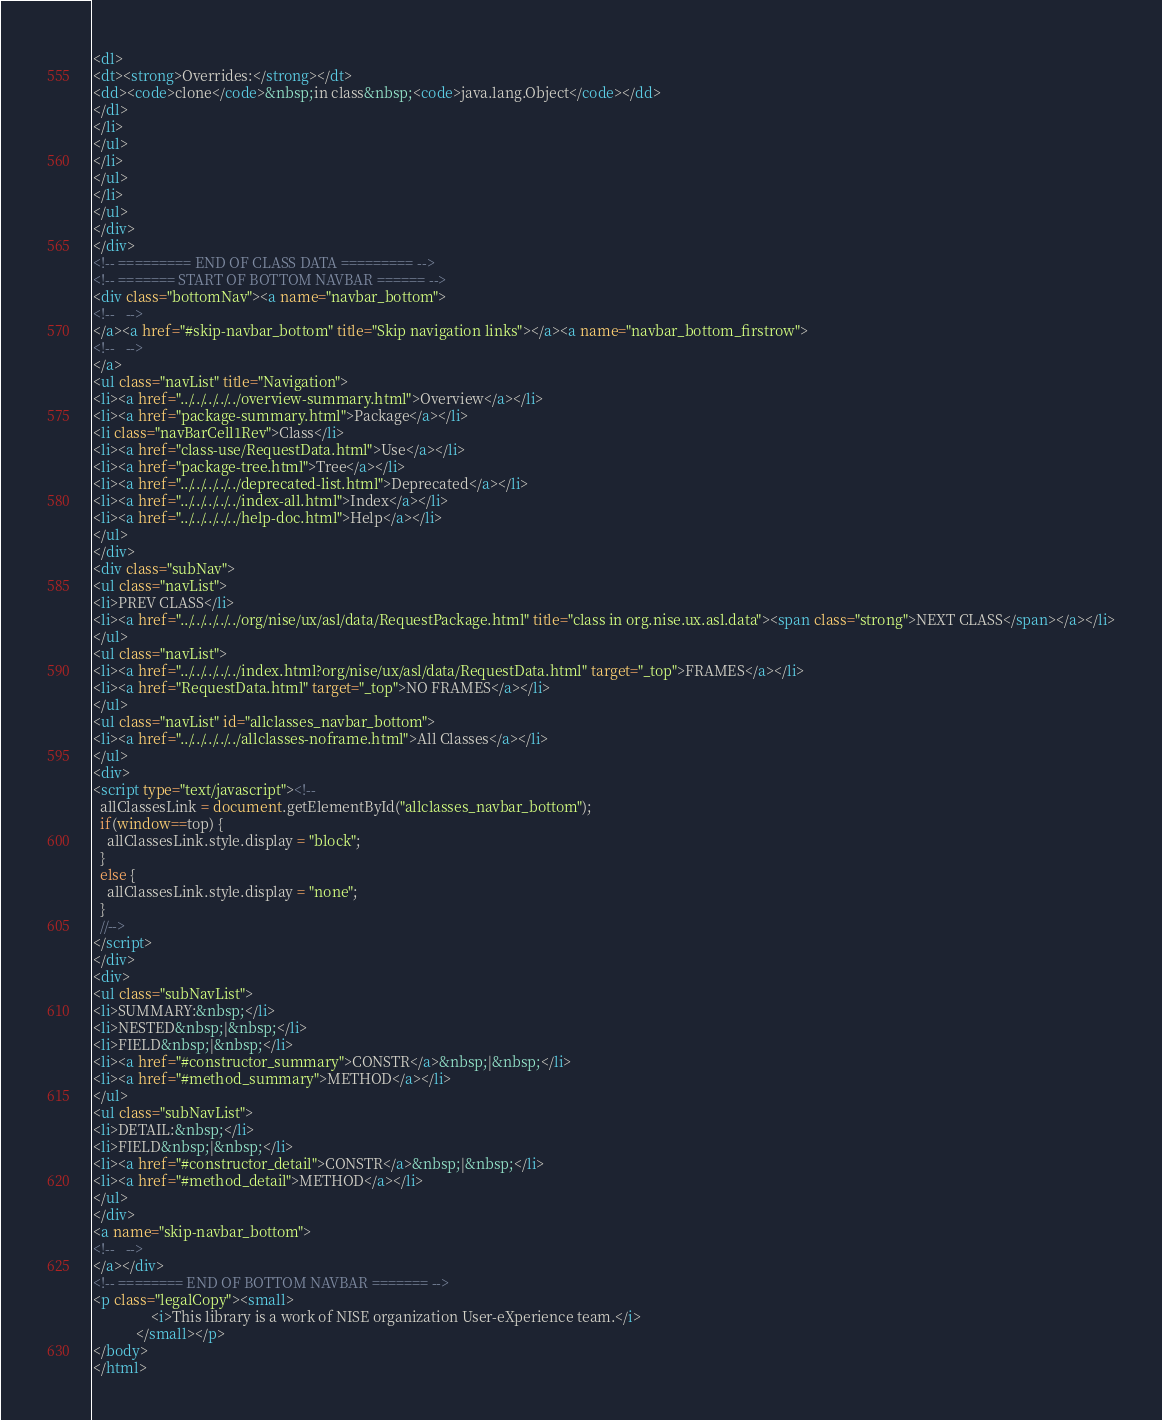Convert code to text. <code><loc_0><loc_0><loc_500><loc_500><_HTML_><dl>
<dt><strong>Overrides:</strong></dt>
<dd><code>clone</code>&nbsp;in class&nbsp;<code>java.lang.Object</code></dd>
</dl>
</li>
</ul>
</li>
</ul>
</li>
</ul>
</div>
</div>
<!-- ========= END OF CLASS DATA ========= -->
<!-- ======= START OF BOTTOM NAVBAR ====== -->
<div class="bottomNav"><a name="navbar_bottom">
<!--   -->
</a><a href="#skip-navbar_bottom" title="Skip navigation links"></a><a name="navbar_bottom_firstrow">
<!--   -->
</a>
<ul class="navList" title="Navigation">
<li><a href="../../../../../overview-summary.html">Overview</a></li>
<li><a href="package-summary.html">Package</a></li>
<li class="navBarCell1Rev">Class</li>
<li><a href="class-use/RequestData.html">Use</a></li>
<li><a href="package-tree.html">Tree</a></li>
<li><a href="../../../../../deprecated-list.html">Deprecated</a></li>
<li><a href="../../../../../index-all.html">Index</a></li>
<li><a href="../../../../../help-doc.html">Help</a></li>
</ul>
</div>
<div class="subNav">
<ul class="navList">
<li>PREV CLASS</li>
<li><a href="../../../../../org/nise/ux/asl/data/RequestPackage.html" title="class in org.nise.ux.asl.data"><span class="strong">NEXT CLASS</span></a></li>
</ul>
<ul class="navList">
<li><a href="../../../../../index.html?org/nise/ux/asl/data/RequestData.html" target="_top">FRAMES</a></li>
<li><a href="RequestData.html" target="_top">NO FRAMES</a></li>
</ul>
<ul class="navList" id="allclasses_navbar_bottom">
<li><a href="../../../../../allclasses-noframe.html">All Classes</a></li>
</ul>
<div>
<script type="text/javascript"><!--
  allClassesLink = document.getElementById("allclasses_navbar_bottom");
  if(window==top) {
    allClassesLink.style.display = "block";
  }
  else {
    allClassesLink.style.display = "none";
  }
  //-->
</script>
</div>
<div>
<ul class="subNavList">
<li>SUMMARY:&nbsp;</li>
<li>NESTED&nbsp;|&nbsp;</li>
<li>FIELD&nbsp;|&nbsp;</li>
<li><a href="#constructor_summary">CONSTR</a>&nbsp;|&nbsp;</li>
<li><a href="#method_summary">METHOD</a></li>
</ul>
<ul class="subNavList">
<li>DETAIL:&nbsp;</li>
<li>FIELD&nbsp;|&nbsp;</li>
<li><a href="#constructor_detail">CONSTR</a>&nbsp;|&nbsp;</li>
<li><a href="#method_detail">METHOD</a></li>
</ul>
</div>
<a name="skip-navbar_bottom">
<!--   -->
</a></div>
<!-- ======== END OF BOTTOM NAVBAR ======= -->
<p class="legalCopy"><small>
				<i>This library is a work of NISE organization User-eXperience team.</i>
			</small></p>
</body>
</html>
</code> 